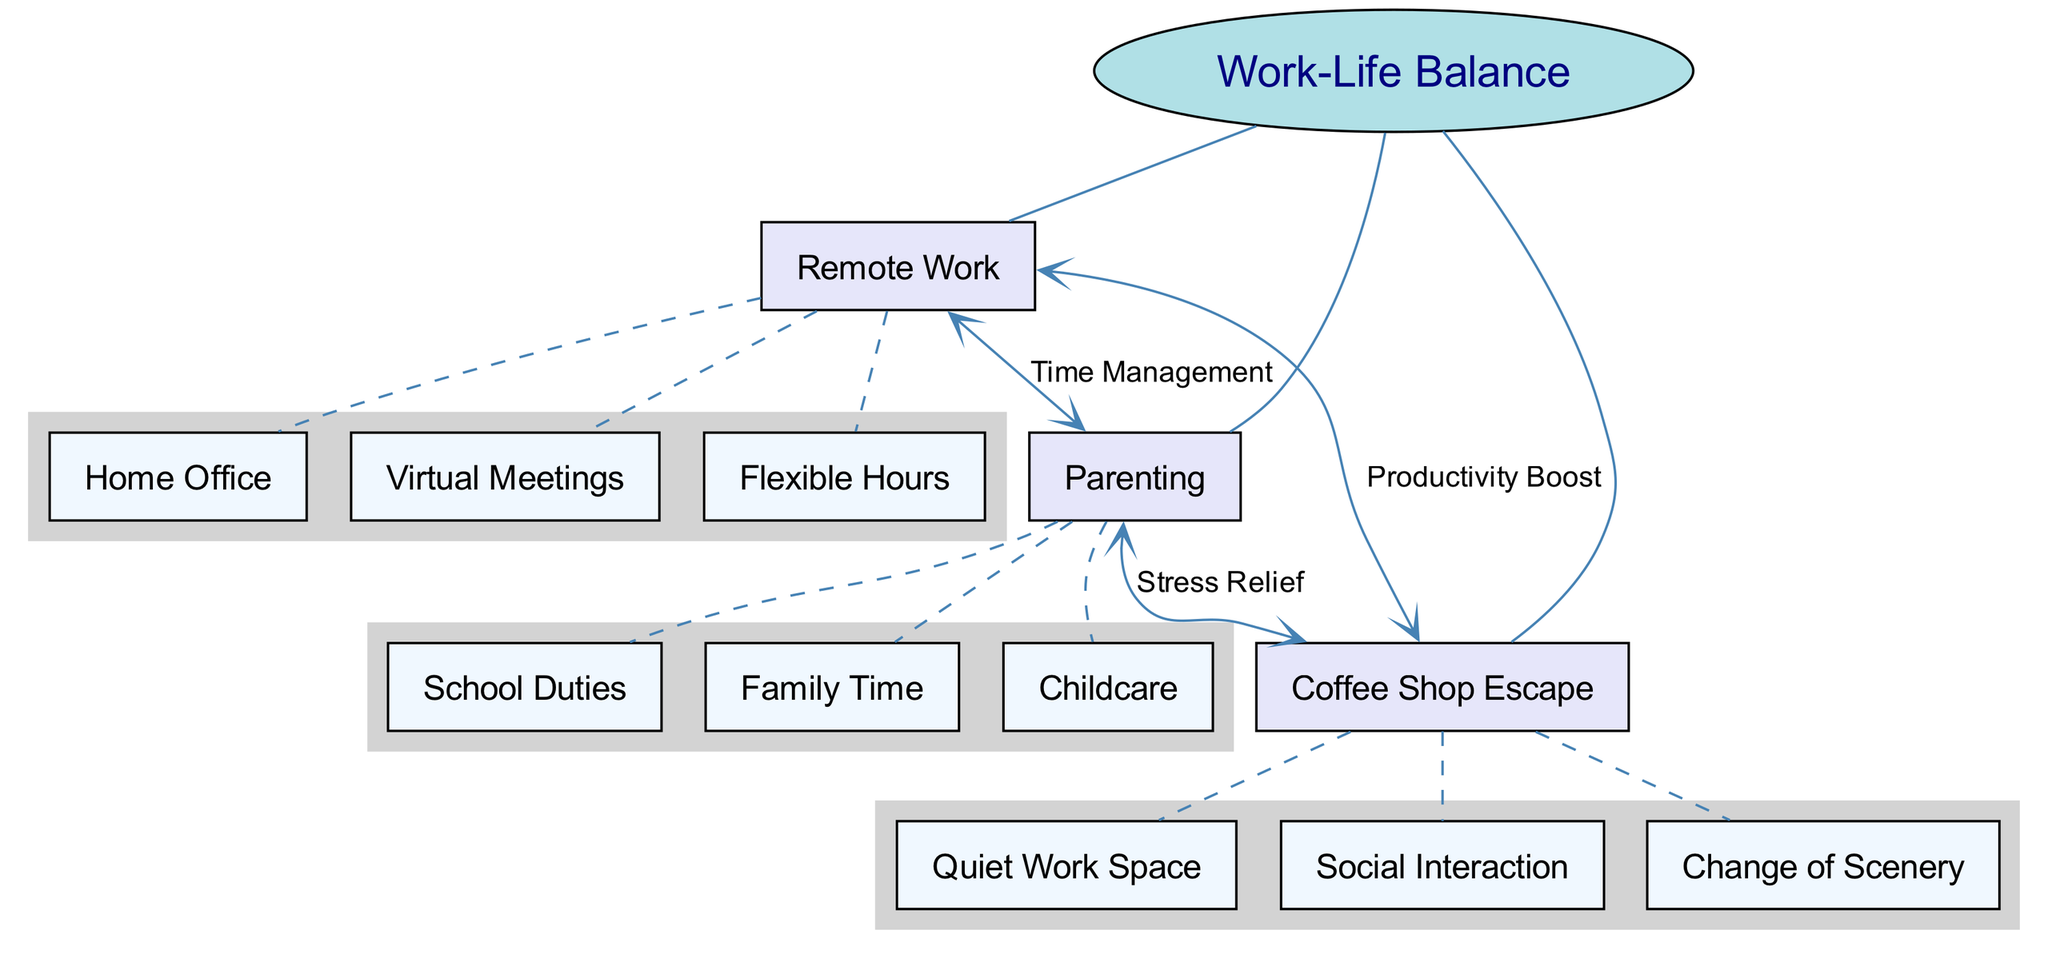What are the main nodes in the diagram? The main nodes in the diagram are the primary categories under the central concept of "Work-Life Balance." They are explicitly labeled as "Remote Work," "Parenting," and "Coffee Shop Escape."
Answer: Remote Work, Parenting, Coffee Shop Escape How many sub-nodes are connected to "Remote Work"? The "Remote Work" node has three sub-nodes connected to it: "Home Office," "Virtual Meetings," and "Flexible Hours." This can be counted directly by observing the edges emanating from the "Remote Work" node to its sub-nodes.
Answer: 3 What is the connection label between "Remote Work" and "Parenting"? The diagram indicates a connection label that describes the relationship between "Remote Work" and "Parenting." This label is "Time Management," which can be found on the edge that connects these two main nodes.
Answer: Time Management What are the benefits of the "Coffee Shop Escape" concerning "Parenting"? The connection between "Parenting" and "Coffee Shop Escape" is labeled "Stress Relief." This shows that one of the benefits of visiting a coffee shop for a parent is the reduction of stress that can arise from parenting responsibilities.
Answer: Stress Relief Which node directly connects to both "Remote Work" and "Coffee Shop Escape"? The node that connects to both "Remote Work" and "Coffee Shop Escape" is "Parenting." This can be determined by checking the edges that lead to both of these main nodes and identifying the common node between them.
Answer: Parenting How many total connections are there in the diagram? To determine the total number of connections, count each unique edge present among the main nodes and their respective sub-nodes. In this case, there are four connections noted: one from "Remote Work" to "Parenting," one from "Remote Work" to "Coffee Shop Escape," one from "Parenting" to "Coffee Shop Escape," and the sub-node connections. Therefore, the total connections are noted by counting and combining them correctly.
Answer: 4 What is the main purpose of the "Coffee Shop Escape" node in the context of remote work? The "Coffee Shop Escape" node is connected to "Remote Work" with the label "Productivity Boost." This implies that utilizing a coffee shop environment serves the purpose of enhancing productivity for someone working remotely.
Answer: Productivity Boost What are the sub-nodes under "Parenting"? The sub-nodes connected to "Parenting" are "Childcare," "School Duties," and "Family Time." This can be identified by looking at the edges that arise from the "Parenting" node to its specific sub-nodes in the diagram.
Answer: Childcare, School Duties, Family Time 